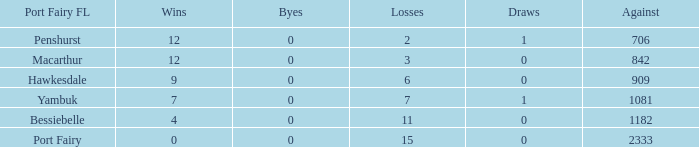When the draws are less than 0, how many byes are there? 0.0. 